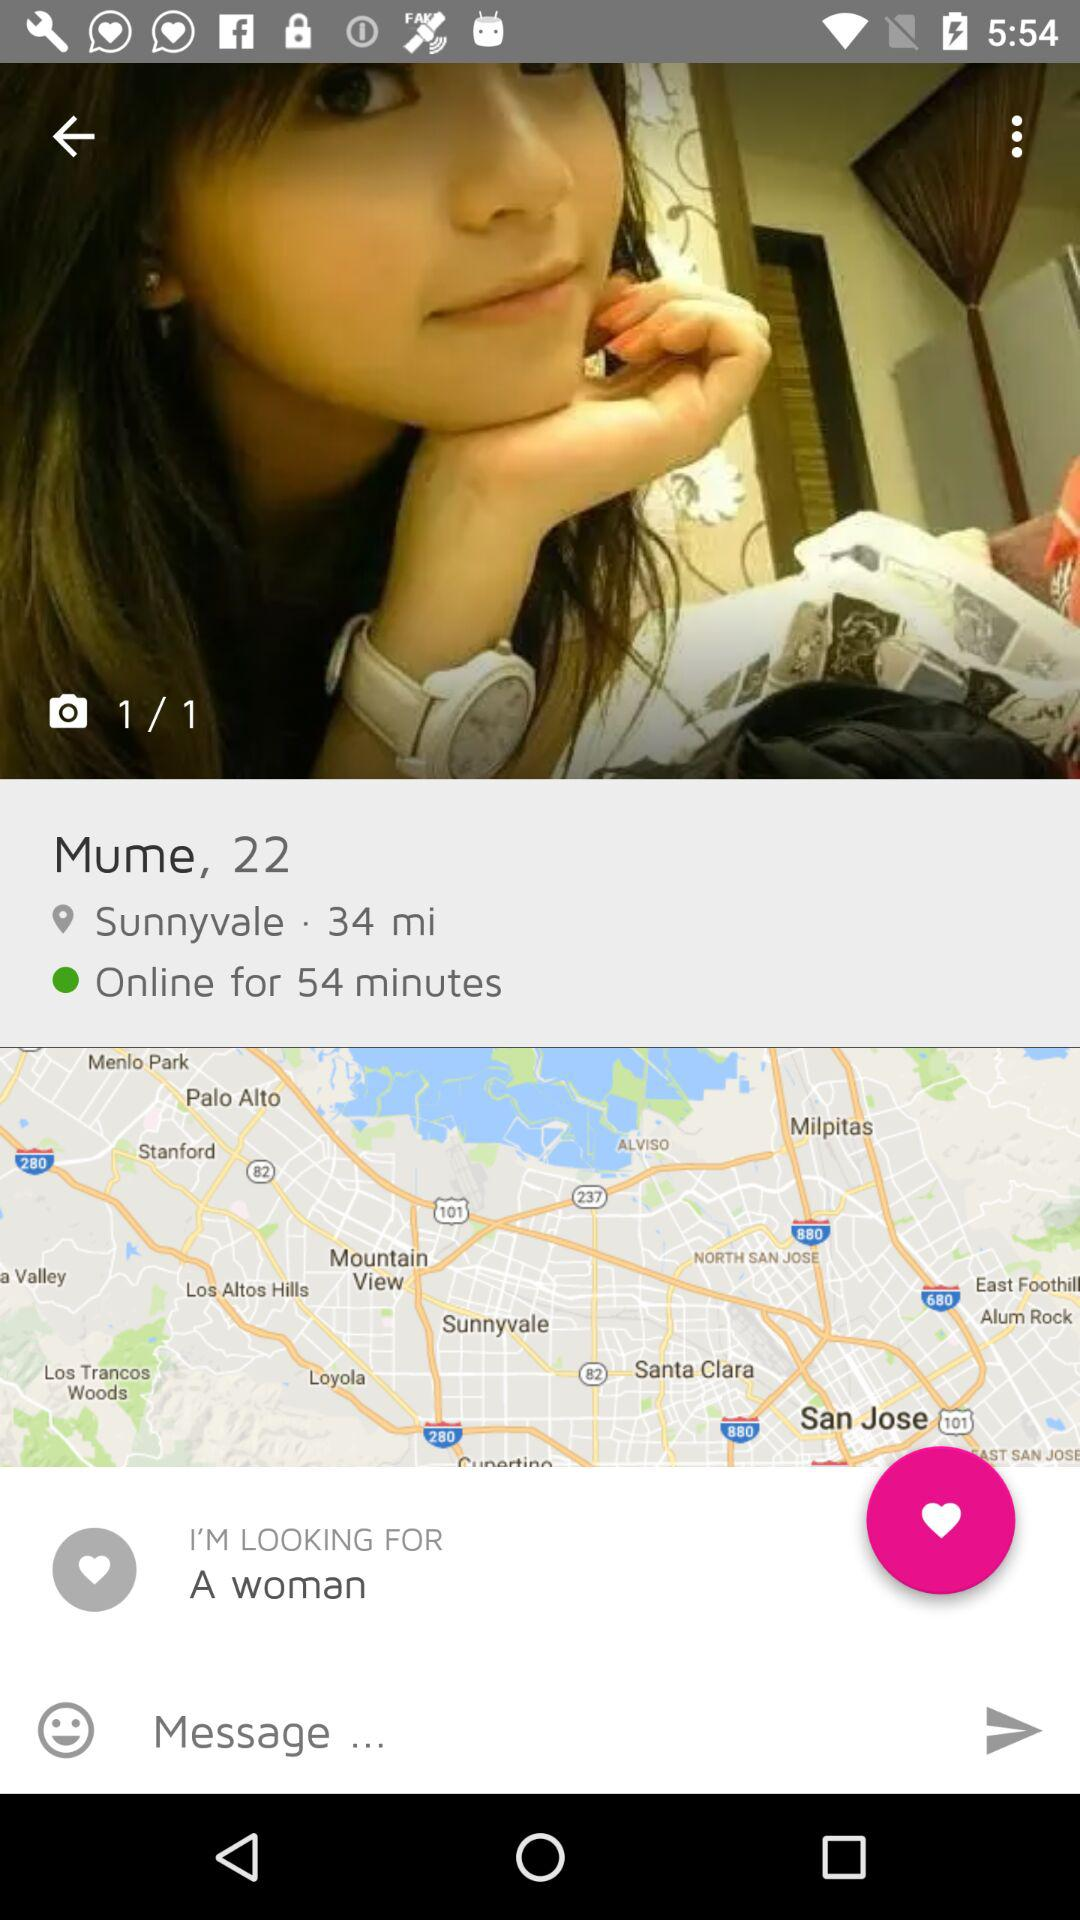For how many minutes is the user online? The user is online for 54 minutes. 